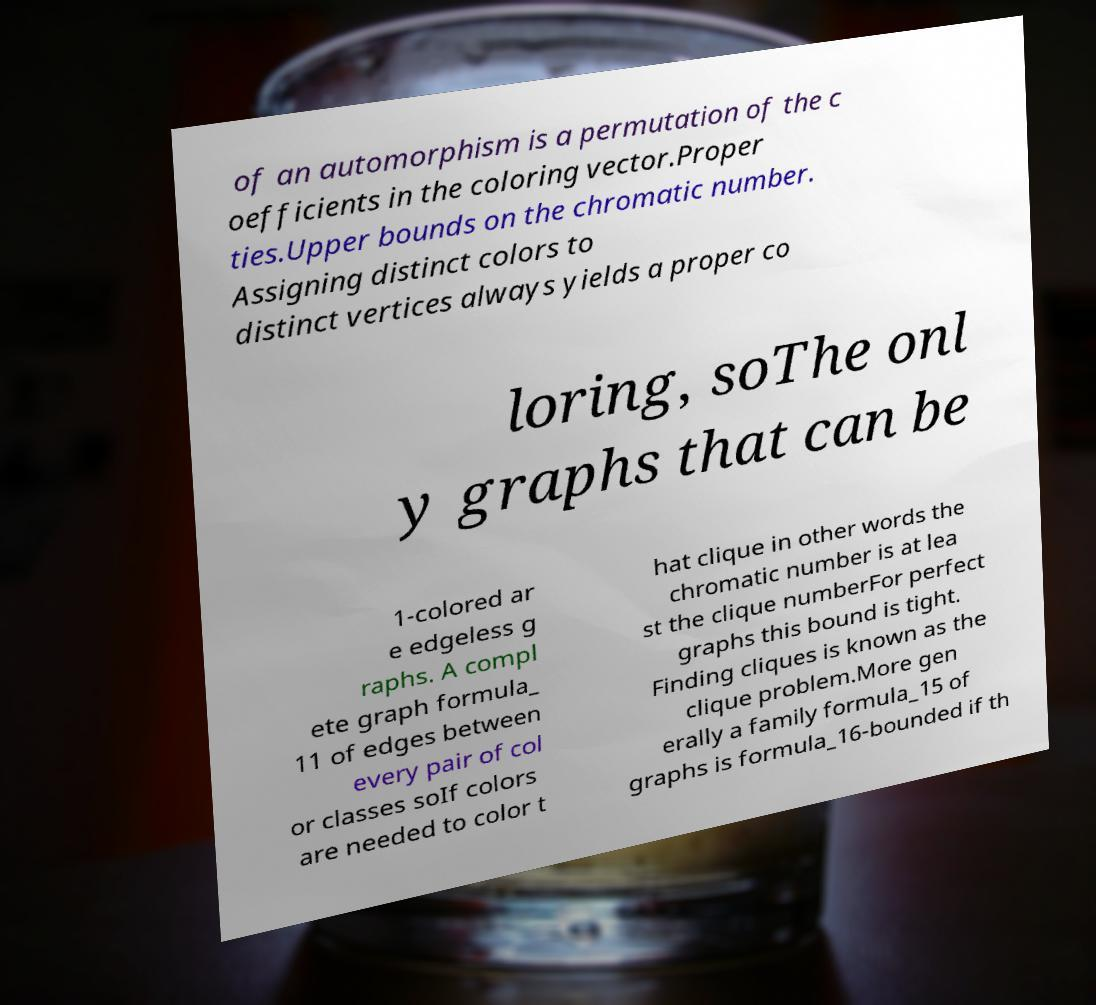For documentation purposes, I need the text within this image transcribed. Could you provide that? of an automorphism is a permutation of the c oefficients in the coloring vector.Proper ties.Upper bounds on the chromatic number. Assigning distinct colors to distinct vertices always yields a proper co loring, soThe onl y graphs that can be 1-colored ar e edgeless g raphs. A compl ete graph formula_ 11 of edges between every pair of col or classes soIf colors are needed to color t hat clique in other words the chromatic number is at lea st the clique numberFor perfect graphs this bound is tight. Finding cliques is known as the clique problem.More gen erally a family formula_15 of graphs is formula_16-bounded if th 